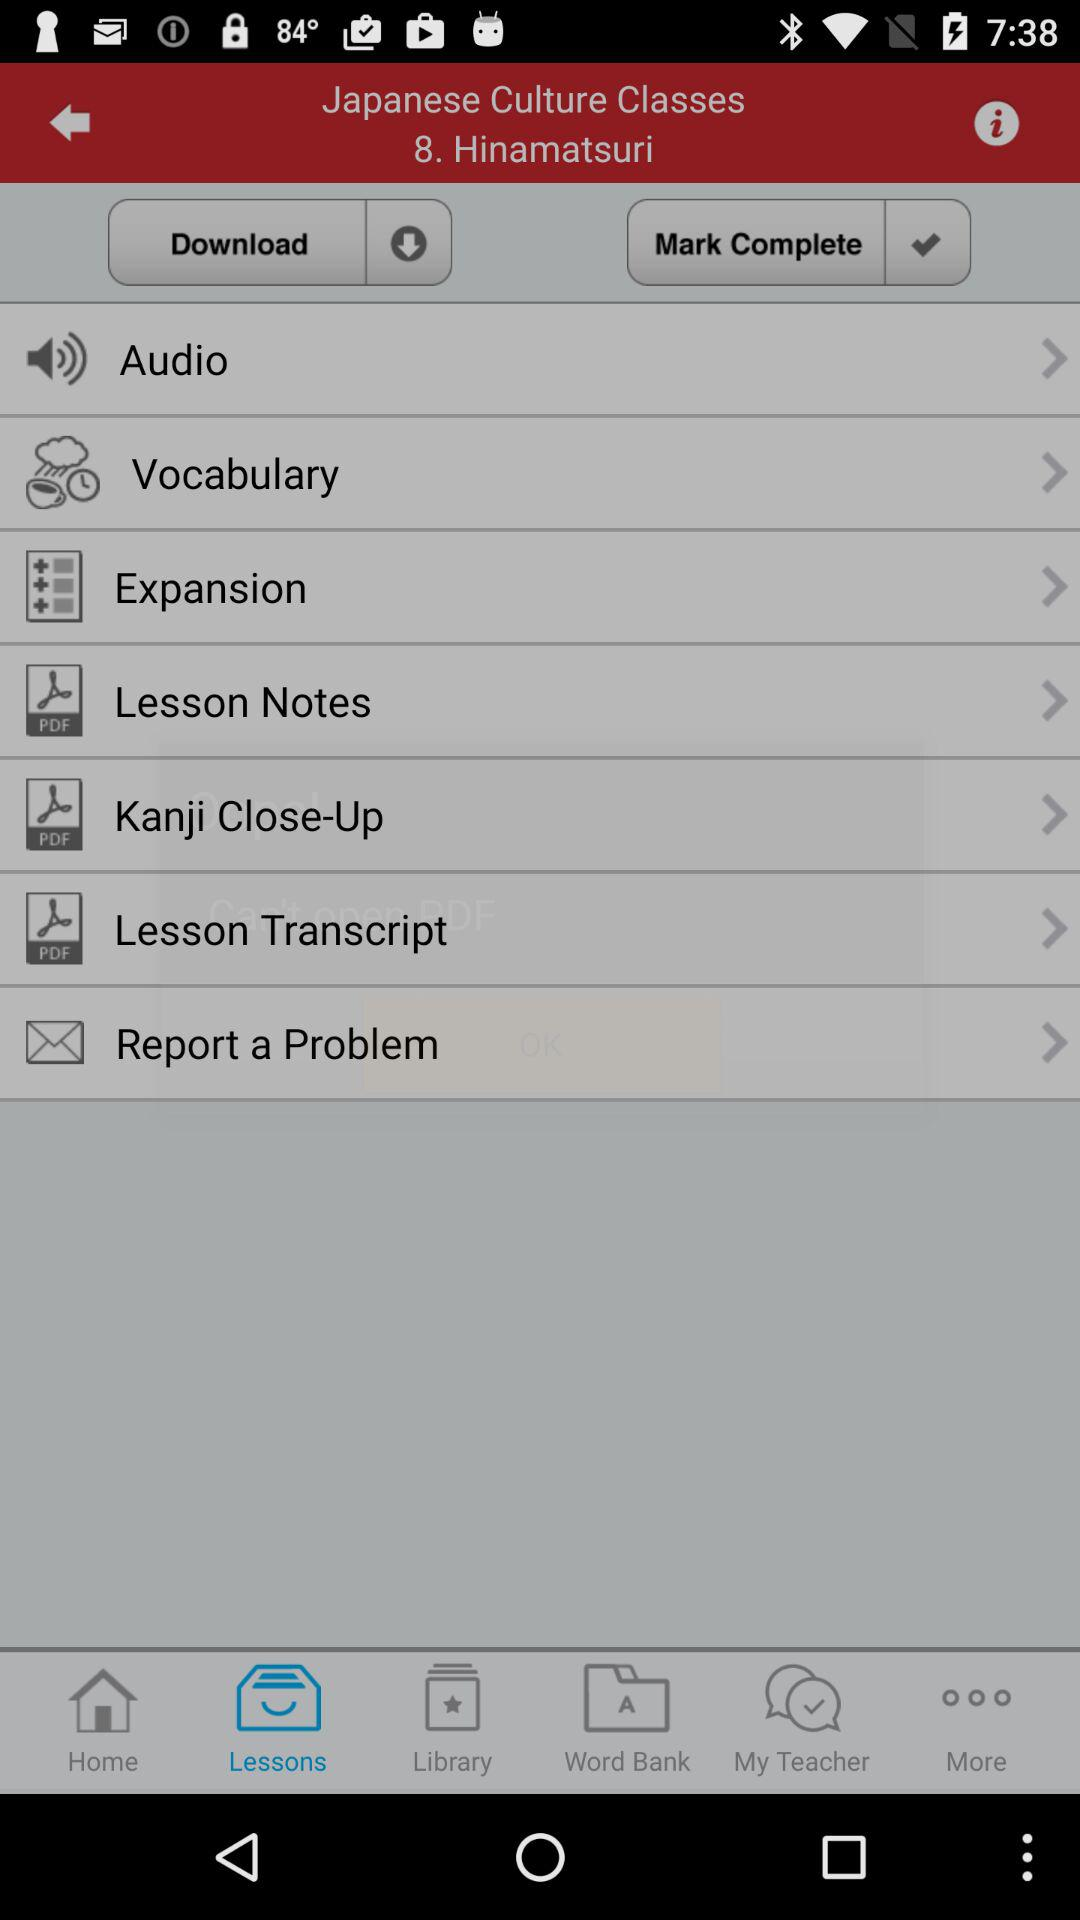Which tab has selected? The selected tab is "Lessons". 